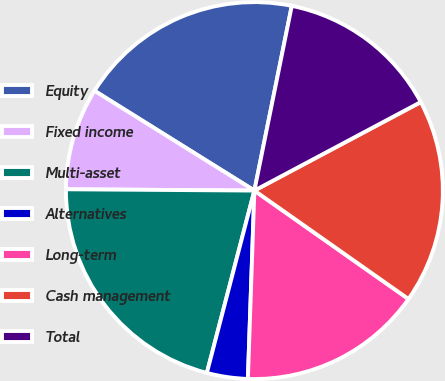Convert chart to OTSL. <chart><loc_0><loc_0><loc_500><loc_500><pie_chart><fcel>Equity<fcel>Fixed income<fcel>Multi-asset<fcel>Alternatives<fcel>Long-term<fcel>Cash management<fcel>Total<nl><fcel>19.3%<fcel>8.77%<fcel>21.05%<fcel>3.51%<fcel>15.79%<fcel>17.54%<fcel>14.04%<nl></chart> 